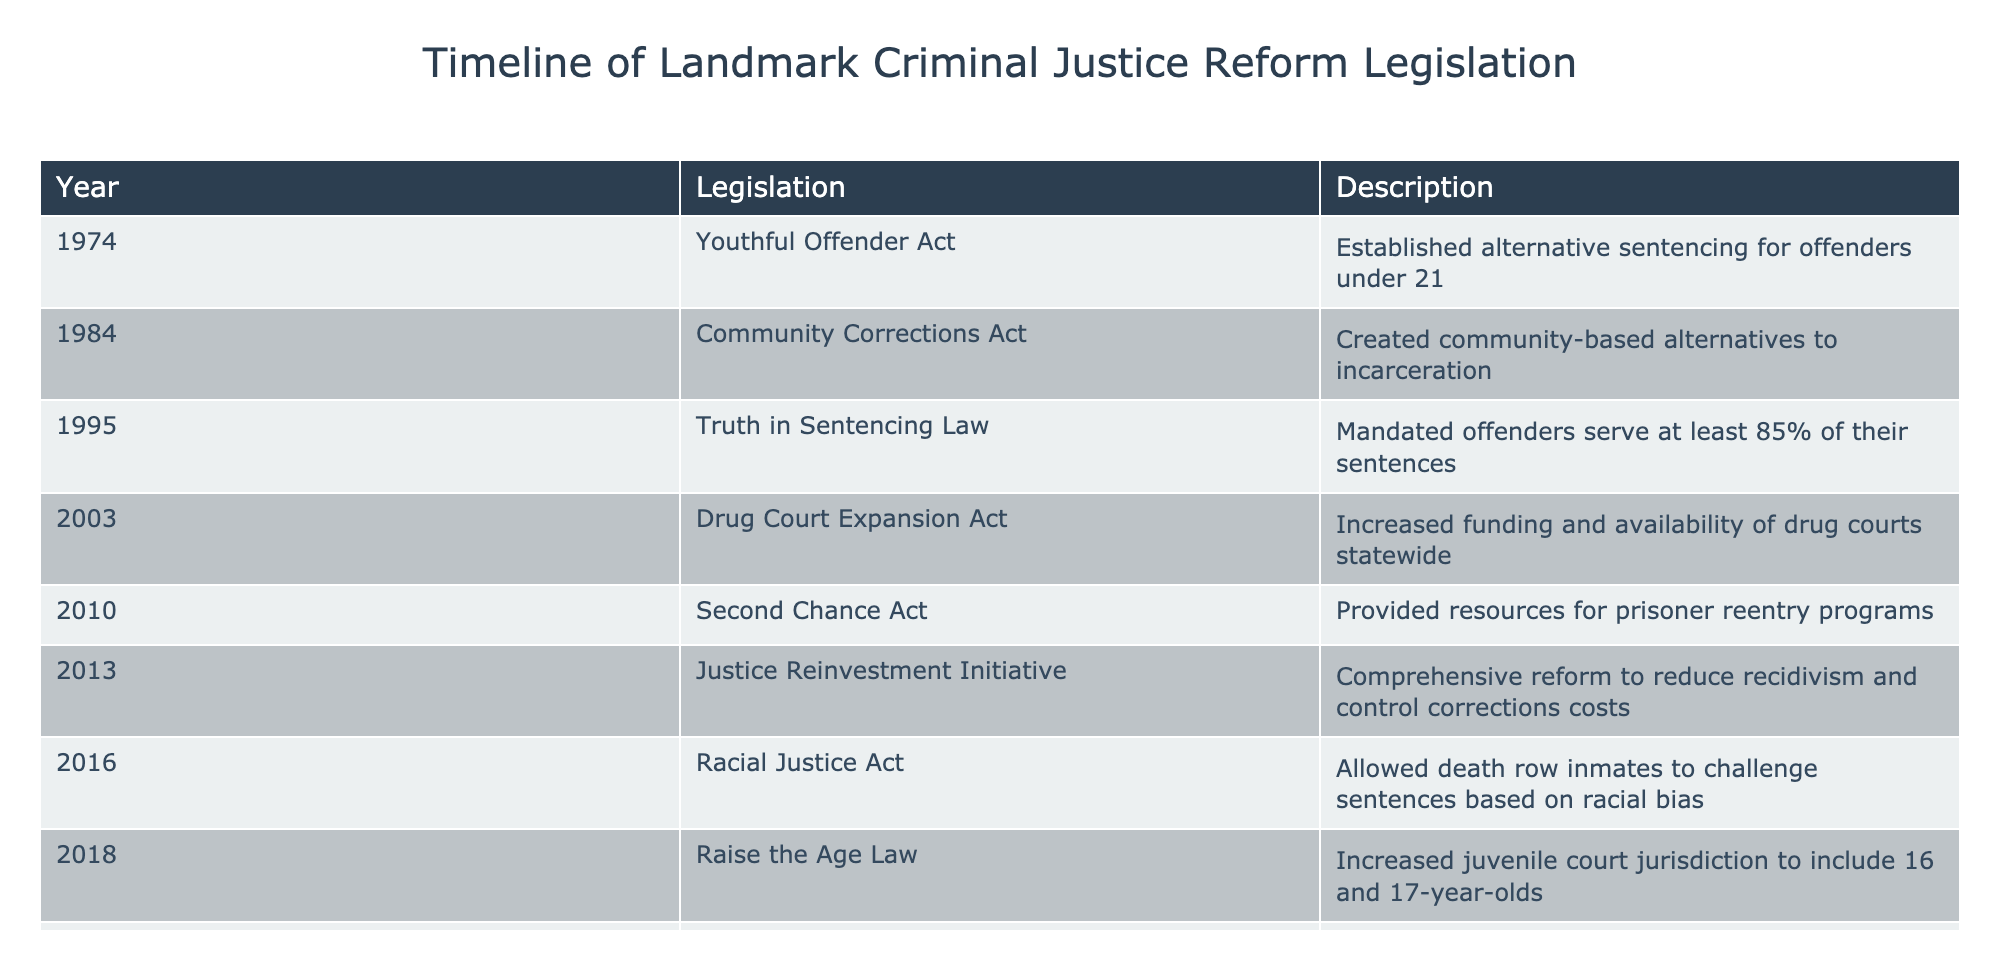What year was the Racial Justice Act enacted? The table lists the enactment years of various legislations, and for the Racial Justice Act, it shows the year 2016.
Answer: 2016 What legislation was established in 1974? Referring to the table, the 1974 legislation is the Youthful Offender Act, which is clearly listed.
Answer: Youthful Offender Act How many reform legislations were enacted between 2000 and 2020? The relevant years from the table are 2003 (Drug Court Expansion Act), 2010 (Second Chance Act), 2013 (Justice Reinvestment Initiative), 2016 (Racial Justice Act), 2018 (Raise the Age Law), and 2020 (SAFE Act), totaling six pieces of legislation.
Answer: 6 Is it true that the Clean Slate Act was enacted before the SAFE Act? The table indicates that the SAFE Act was enacted in 2020 and the Clean Slate Act in 2021, which means the statement is false.
Answer: False Which legislation focused on reducing recidivism? The table indicates that the Justice Reinvestment Initiative, enacted in 2013, was a comprehensive reform aimed at reducing recidivism and controlling corrections costs.
Answer: Justice Reinvestment Initiative What is the difference in years between the establishment of the Youthful Offender Act and the Clean Slate Act? The Youthful Offender Act was established in 1974 and the Clean Slate Act in 2021. The difference is 2021 - 1974 = 47 years.
Answer: 47 years What legislative action was taken in 2022 related to cannabis? According to the table, in 2022, the Marijuana Legalization and Expungement Act was enacted, which legalized cannabis and expunged prior marijuana convictions.
Answer: Marijuana Legalization and Expungement Act Did the Community Corrections Act precede the Truth in Sentencing Law? The Community Corrections Act was enacted in 1984, while the Truth in Sentencing Law was enacted in 1995, indicating that the statement is true.
Answer: True What was the purpose of the Drug Court Expansion Act? The Drug Court Expansion Act, enacted in 2003, aimed to increase funding and availability of drug courts throughout the state, as shown in the table.
Answer: Increase funding and availability of drug courts 